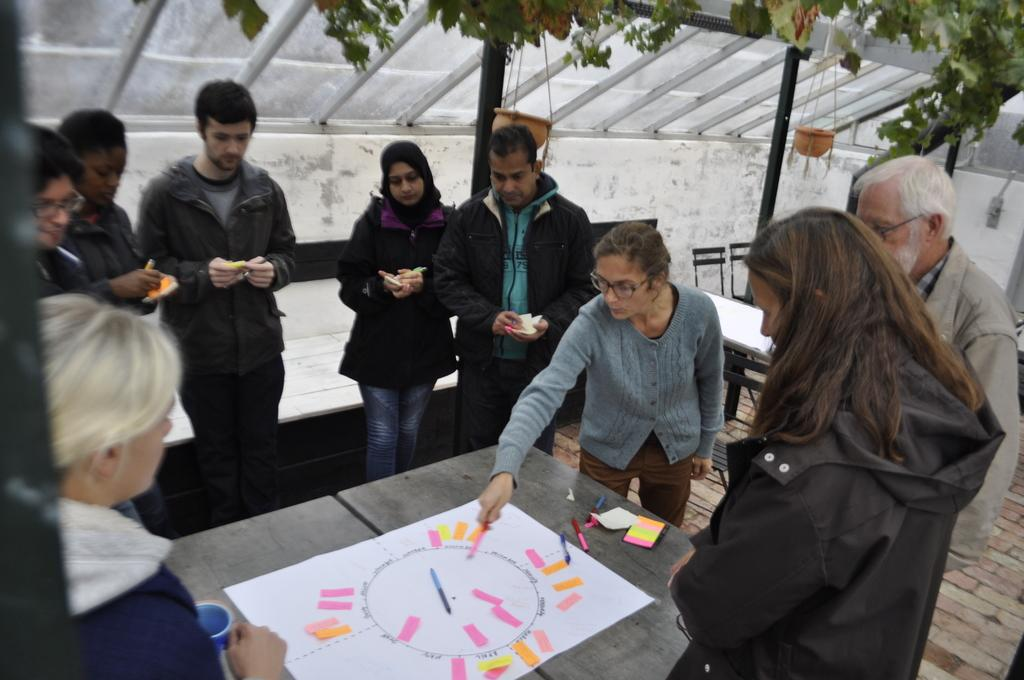What is happening around the table in the image? There are people standing around the table in the image. What is covering the table? There is a sheet on the table. What is on the table besides the sheet? There is a pan and pieces of paper on the table. What can be seen in the background of the image? There is a flower pot and a plant in the background. What type of instrument is being played by the person sitting on the seat in the image? There is no person sitting on a seat in the image, and no instrument is visible. 